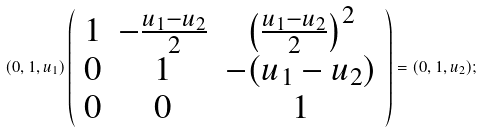<formula> <loc_0><loc_0><loc_500><loc_500>( 0 , 1 , u _ { 1 } ) \left ( \begin{array} { c c c } 1 & - \frac { u _ { 1 } - u _ { 2 } } { 2 } & \left ( \frac { u _ { 1 } - u _ { 2 } } { 2 } \right ) ^ { 2 } \\ 0 & 1 & - ( u _ { 1 } - u _ { 2 } ) \\ 0 & 0 & 1 \end{array} \right ) = ( 0 , 1 , u _ { 2 } ) ;</formula> 